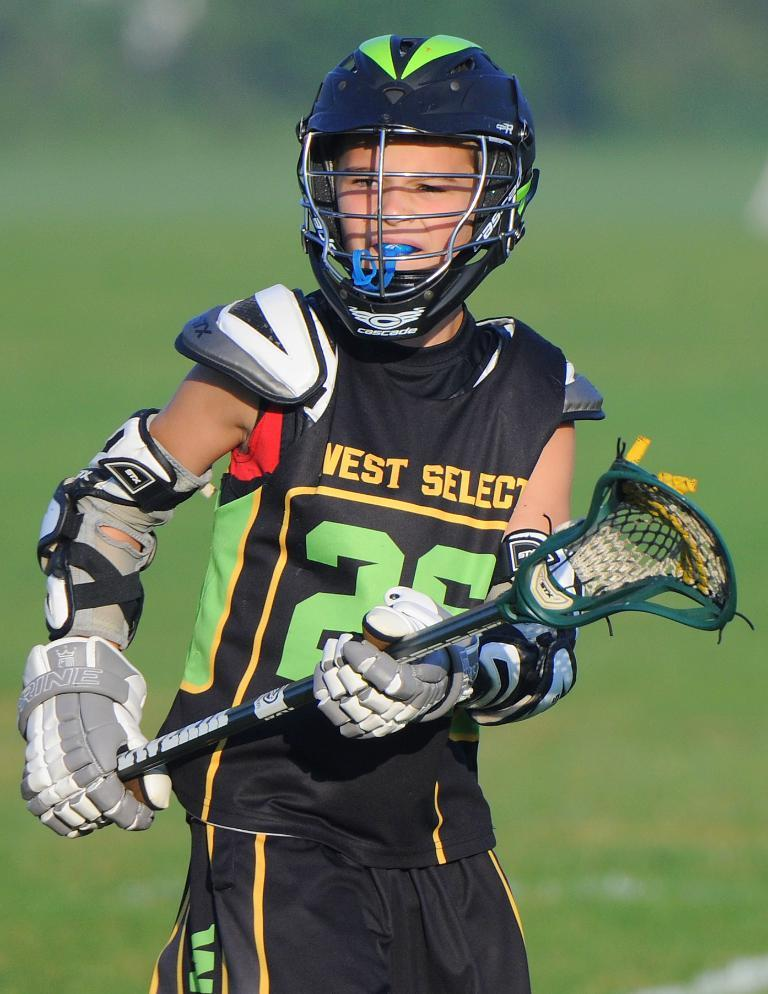Who is the main subject in the image? There is a boy in the image. What is the boy holding in the image? The boy is holding a stick in the image. What color is the stick? The stick is green. Can you describe the background of the image? The background of the image is blurry. How many baby grass plants can be seen growing in the image? There is no grass or baby plants visible in the image. What type of drop can be seen falling from the sky in the image? There is no drop or indication of precipitation in the image. 